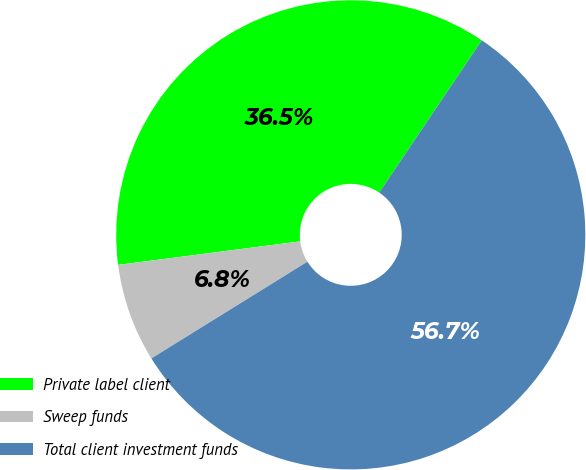<chart> <loc_0><loc_0><loc_500><loc_500><pie_chart><fcel>Private label client<fcel>Sweep funds<fcel>Total client investment funds<nl><fcel>36.48%<fcel>6.79%<fcel>56.73%<nl></chart> 